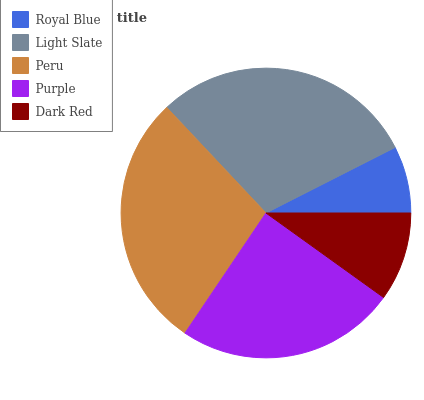Is Royal Blue the minimum?
Answer yes or no. Yes. Is Light Slate the maximum?
Answer yes or no. Yes. Is Peru the minimum?
Answer yes or no. No. Is Peru the maximum?
Answer yes or no. No. Is Light Slate greater than Peru?
Answer yes or no. Yes. Is Peru less than Light Slate?
Answer yes or no. Yes. Is Peru greater than Light Slate?
Answer yes or no. No. Is Light Slate less than Peru?
Answer yes or no. No. Is Purple the high median?
Answer yes or no. Yes. Is Purple the low median?
Answer yes or no. Yes. Is Light Slate the high median?
Answer yes or no. No. Is Dark Red the low median?
Answer yes or no. No. 